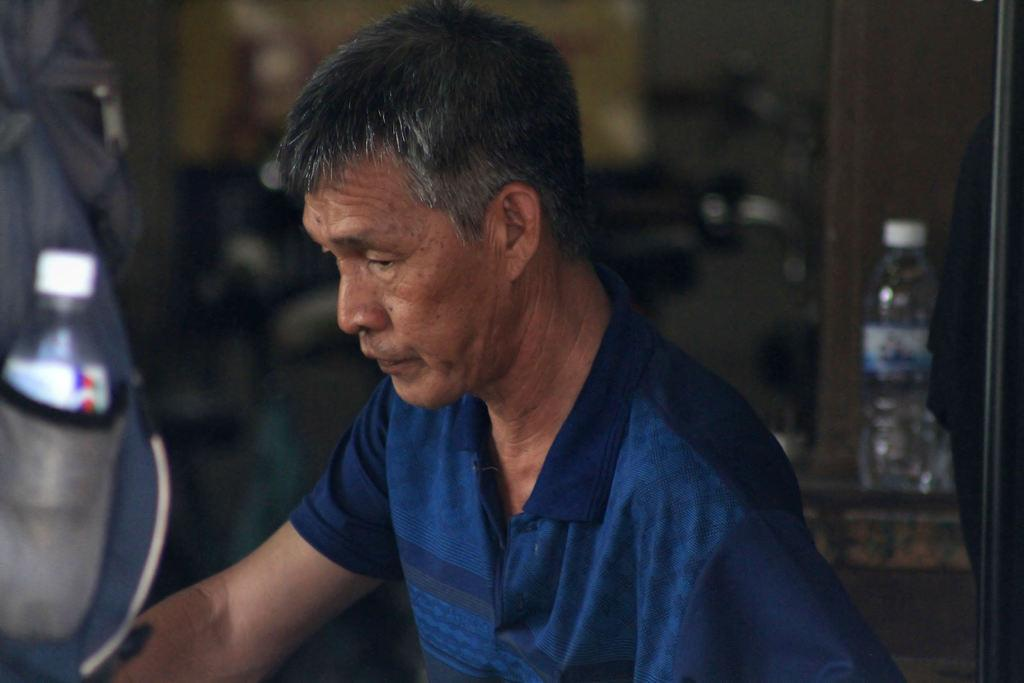Who is present in the image? There is a man in the image. What is the man wearing? The man is wearing a t-shirt. What object can be seen in the image that resembles a bag? There is an object that looks like a bag in the image. What can be seen in the background of the image? There is a water bottle in the background of the image. How would you describe the quality of the image? The image is blurred. What type of cushion is the man sitting on in the image? There is no cushion present in the image, and the man is not sitting down. What educational level does the man in the image have? There is no information about the man's education in the image. 